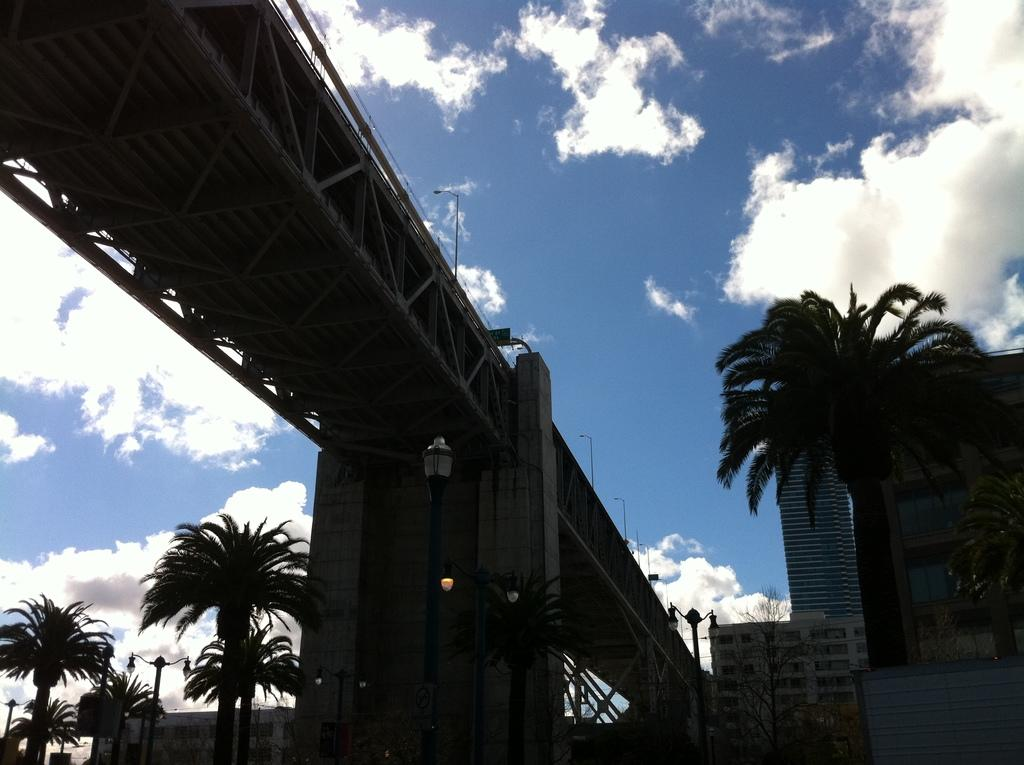What is the main structure in the middle of the image? There is a bridge in the middle of the image. What can be seen below the bridge on either side? Trees and lights are present below the bridge on either side. What is visible in the background on the right side of the image? Buildings are visible in the background on the right side of the image. What is visible above the bridge? The sky is visible above the bridge. What can be observed in the sky? Clouds are present in the sky. Where is the vase placed in the image? There is no vase present in the image. Can you describe the feast taking place on the bridge in the image? There is no feast taking place on the bridge in the image. 